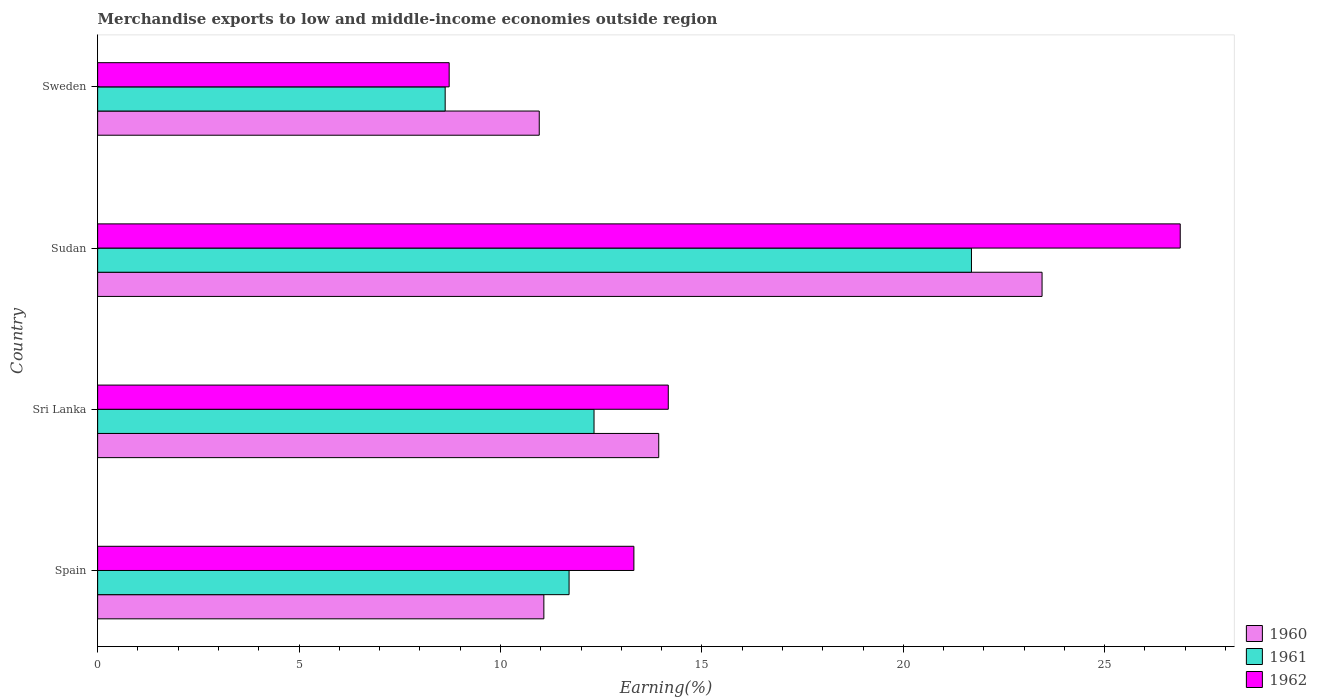How many bars are there on the 2nd tick from the top?
Your response must be concise. 3. What is the label of the 3rd group of bars from the top?
Keep it short and to the point. Sri Lanka. What is the percentage of amount earned from merchandise exports in 1961 in Sweden?
Your answer should be compact. 8.63. Across all countries, what is the maximum percentage of amount earned from merchandise exports in 1961?
Offer a terse response. 21.69. Across all countries, what is the minimum percentage of amount earned from merchandise exports in 1960?
Offer a terse response. 10.96. In which country was the percentage of amount earned from merchandise exports in 1962 maximum?
Your answer should be very brief. Sudan. In which country was the percentage of amount earned from merchandise exports in 1960 minimum?
Your answer should be very brief. Sweden. What is the total percentage of amount earned from merchandise exports in 1961 in the graph?
Your response must be concise. 54.35. What is the difference between the percentage of amount earned from merchandise exports in 1961 in Spain and that in Sweden?
Offer a very short reply. 3.08. What is the difference between the percentage of amount earned from merchandise exports in 1960 in Sudan and the percentage of amount earned from merchandise exports in 1962 in Sweden?
Provide a succinct answer. 14.72. What is the average percentage of amount earned from merchandise exports in 1962 per country?
Offer a terse response. 15.77. What is the difference between the percentage of amount earned from merchandise exports in 1962 and percentage of amount earned from merchandise exports in 1961 in Sri Lanka?
Make the answer very short. 1.84. In how many countries, is the percentage of amount earned from merchandise exports in 1961 greater than 21 %?
Your answer should be compact. 1. What is the ratio of the percentage of amount earned from merchandise exports in 1962 in Sudan to that in Sweden?
Ensure brevity in your answer.  3.08. Is the percentage of amount earned from merchandise exports in 1961 in Sri Lanka less than that in Sweden?
Your answer should be very brief. No. Is the difference between the percentage of amount earned from merchandise exports in 1962 in Sri Lanka and Sudan greater than the difference between the percentage of amount earned from merchandise exports in 1961 in Sri Lanka and Sudan?
Provide a succinct answer. No. What is the difference between the highest and the second highest percentage of amount earned from merchandise exports in 1960?
Provide a succinct answer. 9.52. What is the difference between the highest and the lowest percentage of amount earned from merchandise exports in 1960?
Provide a succinct answer. 12.48. In how many countries, is the percentage of amount earned from merchandise exports in 1960 greater than the average percentage of amount earned from merchandise exports in 1960 taken over all countries?
Provide a succinct answer. 1. What does the 3rd bar from the bottom in Sudan represents?
Give a very brief answer. 1962. Is it the case that in every country, the sum of the percentage of amount earned from merchandise exports in 1962 and percentage of amount earned from merchandise exports in 1960 is greater than the percentage of amount earned from merchandise exports in 1961?
Provide a short and direct response. Yes. How many bars are there?
Provide a short and direct response. 12. Are all the bars in the graph horizontal?
Provide a succinct answer. Yes. How many countries are there in the graph?
Offer a terse response. 4. What is the difference between two consecutive major ticks on the X-axis?
Offer a terse response. 5. Where does the legend appear in the graph?
Give a very brief answer. Bottom right. What is the title of the graph?
Your response must be concise. Merchandise exports to low and middle-income economies outside region. What is the label or title of the X-axis?
Your response must be concise. Earning(%). What is the label or title of the Y-axis?
Offer a terse response. Country. What is the Earning(%) in 1960 in Spain?
Offer a terse response. 11.08. What is the Earning(%) of 1961 in Spain?
Offer a terse response. 11.7. What is the Earning(%) of 1962 in Spain?
Provide a succinct answer. 13.31. What is the Earning(%) of 1960 in Sri Lanka?
Provide a short and direct response. 13.93. What is the Earning(%) in 1961 in Sri Lanka?
Your response must be concise. 12.32. What is the Earning(%) in 1962 in Sri Lanka?
Provide a short and direct response. 14.17. What is the Earning(%) in 1960 in Sudan?
Provide a short and direct response. 23.45. What is the Earning(%) in 1961 in Sudan?
Make the answer very short. 21.69. What is the Earning(%) in 1962 in Sudan?
Ensure brevity in your answer.  26.88. What is the Earning(%) of 1960 in Sweden?
Offer a terse response. 10.96. What is the Earning(%) of 1961 in Sweden?
Your answer should be very brief. 8.63. What is the Earning(%) in 1962 in Sweden?
Your answer should be compact. 8.73. Across all countries, what is the maximum Earning(%) in 1960?
Ensure brevity in your answer.  23.45. Across all countries, what is the maximum Earning(%) in 1961?
Keep it short and to the point. 21.69. Across all countries, what is the maximum Earning(%) in 1962?
Your answer should be very brief. 26.88. Across all countries, what is the minimum Earning(%) in 1960?
Provide a short and direct response. 10.96. Across all countries, what is the minimum Earning(%) of 1961?
Keep it short and to the point. 8.63. Across all countries, what is the minimum Earning(%) of 1962?
Your answer should be compact. 8.73. What is the total Earning(%) in 1960 in the graph?
Your answer should be very brief. 59.41. What is the total Earning(%) in 1961 in the graph?
Give a very brief answer. 54.35. What is the total Earning(%) of 1962 in the graph?
Keep it short and to the point. 63.08. What is the difference between the Earning(%) of 1960 in Spain and that in Sri Lanka?
Provide a succinct answer. -2.85. What is the difference between the Earning(%) in 1961 in Spain and that in Sri Lanka?
Your answer should be very brief. -0.62. What is the difference between the Earning(%) in 1962 in Spain and that in Sri Lanka?
Your answer should be compact. -0.85. What is the difference between the Earning(%) in 1960 in Spain and that in Sudan?
Offer a terse response. -12.37. What is the difference between the Earning(%) in 1961 in Spain and that in Sudan?
Your response must be concise. -9.99. What is the difference between the Earning(%) of 1962 in Spain and that in Sudan?
Your response must be concise. -13.56. What is the difference between the Earning(%) in 1960 in Spain and that in Sweden?
Give a very brief answer. 0.11. What is the difference between the Earning(%) in 1961 in Spain and that in Sweden?
Your answer should be very brief. 3.08. What is the difference between the Earning(%) in 1962 in Spain and that in Sweden?
Your answer should be compact. 4.59. What is the difference between the Earning(%) of 1960 in Sri Lanka and that in Sudan?
Your answer should be compact. -9.52. What is the difference between the Earning(%) in 1961 in Sri Lanka and that in Sudan?
Provide a short and direct response. -9.37. What is the difference between the Earning(%) of 1962 in Sri Lanka and that in Sudan?
Your answer should be compact. -12.71. What is the difference between the Earning(%) in 1960 in Sri Lanka and that in Sweden?
Provide a succinct answer. 2.97. What is the difference between the Earning(%) of 1961 in Sri Lanka and that in Sweden?
Offer a terse response. 3.7. What is the difference between the Earning(%) of 1962 in Sri Lanka and that in Sweden?
Give a very brief answer. 5.44. What is the difference between the Earning(%) of 1960 in Sudan and that in Sweden?
Offer a terse response. 12.48. What is the difference between the Earning(%) of 1961 in Sudan and that in Sweden?
Your response must be concise. 13.07. What is the difference between the Earning(%) of 1962 in Sudan and that in Sweden?
Keep it short and to the point. 18.15. What is the difference between the Earning(%) in 1960 in Spain and the Earning(%) in 1961 in Sri Lanka?
Offer a terse response. -1.25. What is the difference between the Earning(%) of 1960 in Spain and the Earning(%) of 1962 in Sri Lanka?
Ensure brevity in your answer.  -3.09. What is the difference between the Earning(%) in 1961 in Spain and the Earning(%) in 1962 in Sri Lanka?
Your answer should be very brief. -2.46. What is the difference between the Earning(%) of 1960 in Spain and the Earning(%) of 1961 in Sudan?
Provide a short and direct response. -10.62. What is the difference between the Earning(%) of 1960 in Spain and the Earning(%) of 1962 in Sudan?
Make the answer very short. -15.8. What is the difference between the Earning(%) in 1961 in Spain and the Earning(%) in 1962 in Sudan?
Ensure brevity in your answer.  -15.17. What is the difference between the Earning(%) in 1960 in Spain and the Earning(%) in 1961 in Sweden?
Give a very brief answer. 2.45. What is the difference between the Earning(%) in 1960 in Spain and the Earning(%) in 1962 in Sweden?
Your response must be concise. 2.35. What is the difference between the Earning(%) of 1961 in Spain and the Earning(%) of 1962 in Sweden?
Provide a short and direct response. 2.98. What is the difference between the Earning(%) in 1960 in Sri Lanka and the Earning(%) in 1961 in Sudan?
Your answer should be compact. -7.76. What is the difference between the Earning(%) in 1960 in Sri Lanka and the Earning(%) in 1962 in Sudan?
Keep it short and to the point. -12.95. What is the difference between the Earning(%) of 1961 in Sri Lanka and the Earning(%) of 1962 in Sudan?
Offer a very short reply. -14.55. What is the difference between the Earning(%) of 1960 in Sri Lanka and the Earning(%) of 1961 in Sweden?
Ensure brevity in your answer.  5.3. What is the difference between the Earning(%) in 1960 in Sri Lanka and the Earning(%) in 1962 in Sweden?
Provide a succinct answer. 5.2. What is the difference between the Earning(%) of 1961 in Sri Lanka and the Earning(%) of 1962 in Sweden?
Provide a short and direct response. 3.6. What is the difference between the Earning(%) in 1960 in Sudan and the Earning(%) in 1961 in Sweden?
Make the answer very short. 14.82. What is the difference between the Earning(%) in 1960 in Sudan and the Earning(%) in 1962 in Sweden?
Your answer should be very brief. 14.72. What is the difference between the Earning(%) of 1961 in Sudan and the Earning(%) of 1962 in Sweden?
Make the answer very short. 12.97. What is the average Earning(%) in 1960 per country?
Provide a short and direct response. 14.85. What is the average Earning(%) in 1961 per country?
Your response must be concise. 13.59. What is the average Earning(%) of 1962 per country?
Your answer should be very brief. 15.77. What is the difference between the Earning(%) of 1960 and Earning(%) of 1961 in Spain?
Give a very brief answer. -0.63. What is the difference between the Earning(%) in 1960 and Earning(%) in 1962 in Spain?
Ensure brevity in your answer.  -2.24. What is the difference between the Earning(%) of 1961 and Earning(%) of 1962 in Spain?
Offer a very short reply. -1.61. What is the difference between the Earning(%) of 1960 and Earning(%) of 1961 in Sri Lanka?
Provide a succinct answer. 1.61. What is the difference between the Earning(%) of 1960 and Earning(%) of 1962 in Sri Lanka?
Your answer should be compact. -0.24. What is the difference between the Earning(%) of 1961 and Earning(%) of 1962 in Sri Lanka?
Provide a short and direct response. -1.84. What is the difference between the Earning(%) in 1960 and Earning(%) in 1961 in Sudan?
Your answer should be very brief. 1.75. What is the difference between the Earning(%) of 1960 and Earning(%) of 1962 in Sudan?
Make the answer very short. -3.43. What is the difference between the Earning(%) of 1961 and Earning(%) of 1962 in Sudan?
Give a very brief answer. -5.18. What is the difference between the Earning(%) in 1960 and Earning(%) in 1961 in Sweden?
Ensure brevity in your answer.  2.34. What is the difference between the Earning(%) of 1960 and Earning(%) of 1962 in Sweden?
Provide a succinct answer. 2.24. What is the difference between the Earning(%) of 1961 and Earning(%) of 1962 in Sweden?
Your answer should be very brief. -0.1. What is the ratio of the Earning(%) of 1960 in Spain to that in Sri Lanka?
Keep it short and to the point. 0.8. What is the ratio of the Earning(%) in 1961 in Spain to that in Sri Lanka?
Offer a very short reply. 0.95. What is the ratio of the Earning(%) of 1962 in Spain to that in Sri Lanka?
Give a very brief answer. 0.94. What is the ratio of the Earning(%) in 1960 in Spain to that in Sudan?
Provide a succinct answer. 0.47. What is the ratio of the Earning(%) in 1961 in Spain to that in Sudan?
Offer a very short reply. 0.54. What is the ratio of the Earning(%) of 1962 in Spain to that in Sudan?
Offer a very short reply. 0.5. What is the ratio of the Earning(%) of 1960 in Spain to that in Sweden?
Offer a very short reply. 1.01. What is the ratio of the Earning(%) of 1961 in Spain to that in Sweden?
Make the answer very short. 1.36. What is the ratio of the Earning(%) in 1962 in Spain to that in Sweden?
Provide a short and direct response. 1.53. What is the ratio of the Earning(%) of 1960 in Sri Lanka to that in Sudan?
Your answer should be compact. 0.59. What is the ratio of the Earning(%) in 1961 in Sri Lanka to that in Sudan?
Provide a succinct answer. 0.57. What is the ratio of the Earning(%) in 1962 in Sri Lanka to that in Sudan?
Keep it short and to the point. 0.53. What is the ratio of the Earning(%) of 1960 in Sri Lanka to that in Sweden?
Offer a very short reply. 1.27. What is the ratio of the Earning(%) of 1961 in Sri Lanka to that in Sweden?
Keep it short and to the point. 1.43. What is the ratio of the Earning(%) in 1962 in Sri Lanka to that in Sweden?
Ensure brevity in your answer.  1.62. What is the ratio of the Earning(%) of 1960 in Sudan to that in Sweden?
Offer a very short reply. 2.14. What is the ratio of the Earning(%) of 1961 in Sudan to that in Sweden?
Your response must be concise. 2.51. What is the ratio of the Earning(%) of 1962 in Sudan to that in Sweden?
Your answer should be compact. 3.08. What is the difference between the highest and the second highest Earning(%) in 1960?
Provide a short and direct response. 9.52. What is the difference between the highest and the second highest Earning(%) of 1961?
Give a very brief answer. 9.37. What is the difference between the highest and the second highest Earning(%) of 1962?
Provide a short and direct response. 12.71. What is the difference between the highest and the lowest Earning(%) in 1960?
Ensure brevity in your answer.  12.48. What is the difference between the highest and the lowest Earning(%) in 1961?
Give a very brief answer. 13.07. What is the difference between the highest and the lowest Earning(%) in 1962?
Provide a succinct answer. 18.15. 